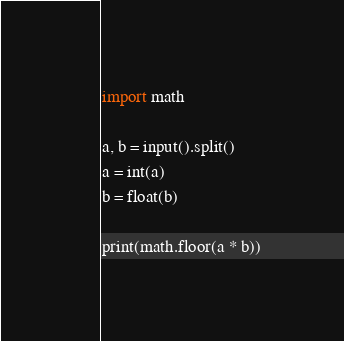Convert code to text. <code><loc_0><loc_0><loc_500><loc_500><_Python_>import math

a, b = input().split()
a = int(a)
b = float(b)

print(math.floor(a * b))
</code> 